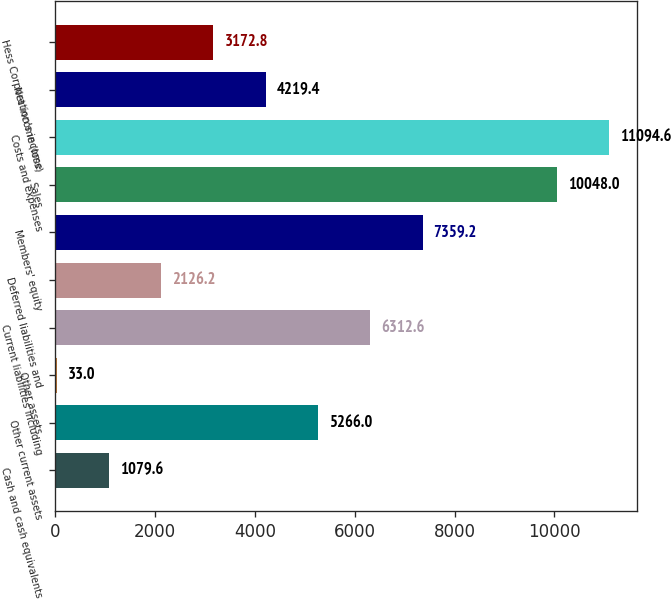Convert chart to OTSL. <chart><loc_0><loc_0><loc_500><loc_500><bar_chart><fcel>Cash and cash equivalents<fcel>Other current assets<fcel>Other assets<fcel>Current liabilities including<fcel>Deferred liabilities and<fcel>Members' equity<fcel>Sales<fcel>Costs and expenses<fcel>Net income (loss)<fcel>Hess Corporation's income<nl><fcel>1079.6<fcel>5266<fcel>33<fcel>6312.6<fcel>2126.2<fcel>7359.2<fcel>10048<fcel>11094.6<fcel>4219.4<fcel>3172.8<nl></chart> 